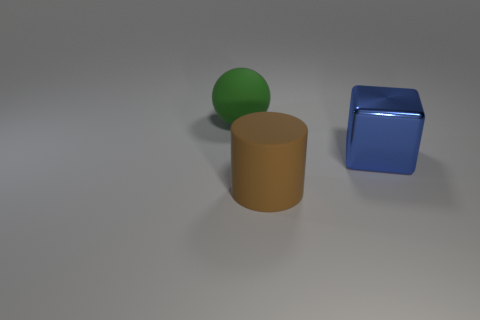Add 1 tiny green matte spheres. How many tiny green matte spheres exist? 1 Add 1 large green rubber balls. How many objects exist? 4 Subtract 0 gray balls. How many objects are left? 3 Subtract all cubes. How many objects are left? 2 Subtract 1 balls. How many balls are left? 0 Subtract all gray balls. Subtract all gray cylinders. How many balls are left? 1 Subtract all green objects. Subtract all big blue things. How many objects are left? 1 Add 1 large green rubber spheres. How many large green rubber spheres are left? 2 